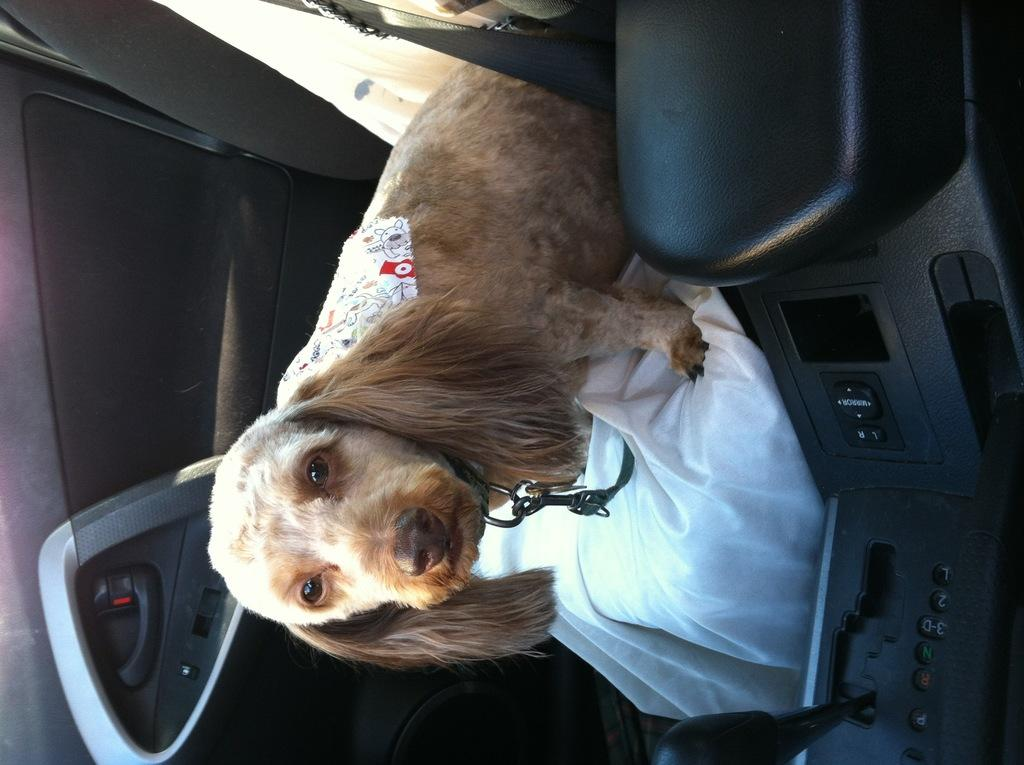What type of animal is present in the image? There is a dog in the image. Where is the dog located in the image? The dog is sitting on a car seat. What type of toys can be seen with the dog in the image? There are no toys visible in the image; it only features a dog sitting on a car seat. 